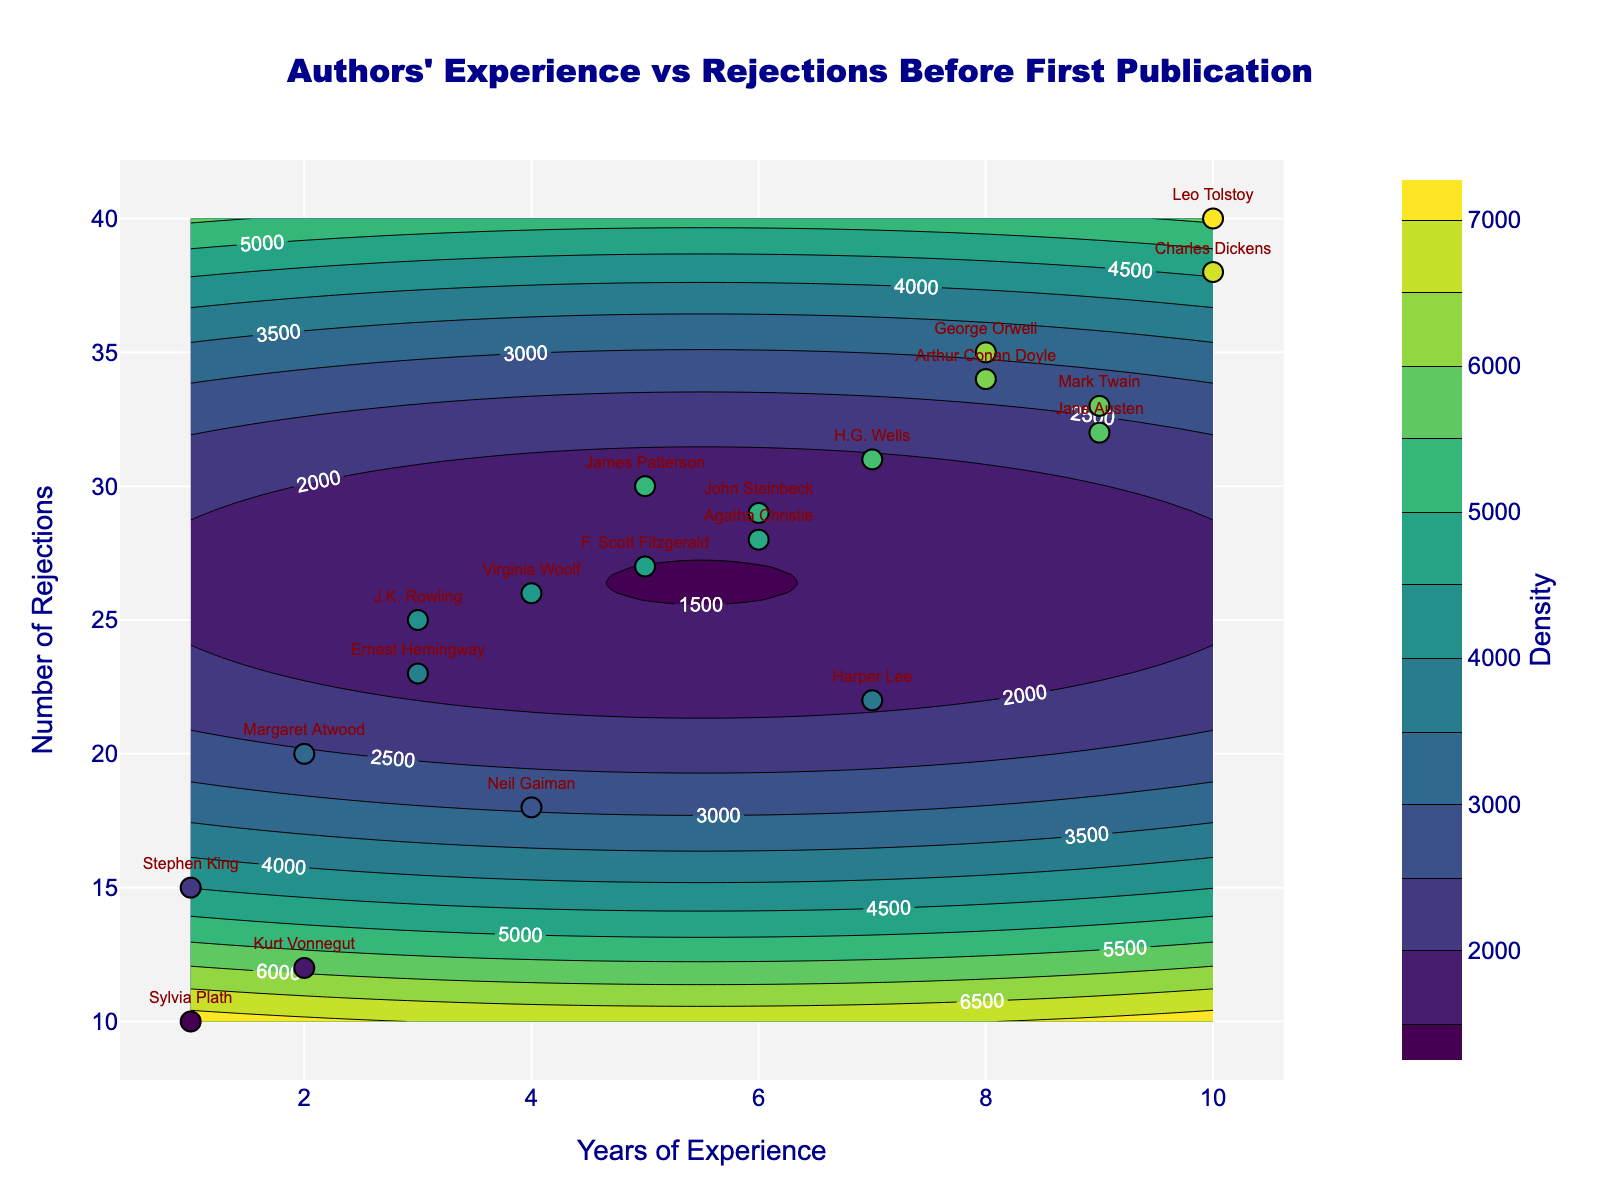Who has the most number of rejections before their first publication? Charles Dickens has the most number of rejections before their first publication, as indicated by the highest point on the y-axis that is labeled within the figure.
Answer: Charles Dickens Which author had the least number of years of experience before their first publication? Sylvia Plath and Stephen King both had the least number of years of experience before their first publication, as they are both at the lowest point on the x-axis labeled within the figure.
Answer: Sylvia Plath, Stephen King What is the average number of rejections experienced by authors with 5 or more years of experience before their first publication? Considering the authors with 5 or more years of experience (James Patterson, Agatha Christie, George Orwell, Harper Lee, Leo Tolstoy, Jane Austen, John Steinbeck, H.G. Wells, Arthur Conan Doyle, Mark Twain, and Charles Dickens), we add their rejections (30+28+35+22+40+32+29+31+34+33+38) totaling 352 and divide by the 11 authors: 352/11 ≈ 32
Answer: 32 How does the experience of Jane Austen compare to that of Leo Tolstoy in terms of years and rejections? Jane Austen had 9 years of experience and 32 rejections, while Leo Tolstoy had 10 years of experience and 40 rejections. In terms of years, Jane Austen had 1 year less experience, but in terms of rejections, she had 8 fewer rejections than Leo Tolstoy.
Answer: Less than/Less than Which author had more rejections: J.K. Rowling or Ernest Hemingway? J.K. Rowling had 25 rejections, while Ernest Hemingway had 23 rejections. Therefore, J.K. Rowling had more rejections.
Answer: J.K. Rowling What visual clues indicate a higher density of data points in the contour plot? The darker contour regions and tighter packed lines indicate a higher density of data points. This is where more authors' data points are clustered closer together in terms of years of experience and rejections.
Answer: Darker contour regions How many authors had exactly 3 years of experience before their first publication, and who were they? Two authors had exactly 3 years of experience before their first publication: J.K. Rowling and Ernest Hemingway, as indicated by the labels on the corresponding data points.
Answer: 2 (J.K. Rowling, Ernest Hemingway) Compare the rejection experiences of Sylvia Plath and Kurt Vonnegut. Who had more rejections, and by how many? Sylvia Plath had 10 rejections, while Kurt Vonnegut had 12. Kurt Vonnegut had 2 more rejections than Sylvia Plath.
Answer: Kurt Vonnegut, 2 Who had 6 years of experience and a significant number of rejections before their first publication? Both Agatha Christie and John Steinbeck had 6 years of experience; Agatha Christie had 28 rejections and John Steinbeck had 29 rejections. These authors are indicated by the labels on their corresponding markers.
Answer: Agatha Christie, John Steinbeck 